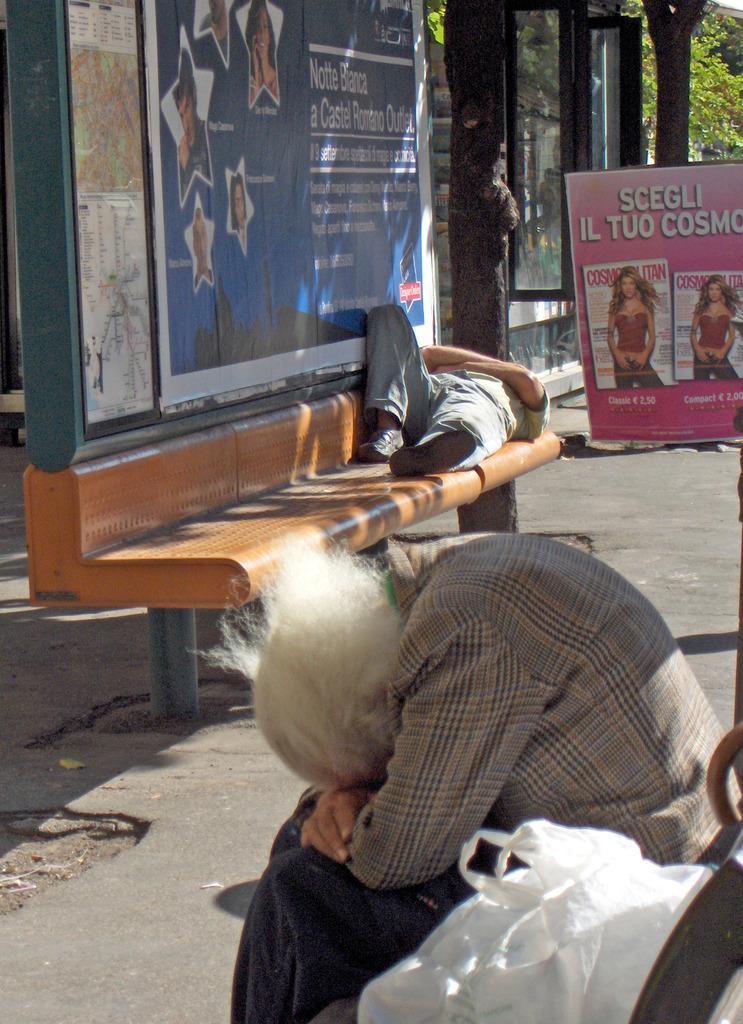Could you give a brief overview of what you see in this image? In the center of the image we can see a man is lying on a bench. At the bottom of the image we can see a person is sitting on a bench and also we can see plastic cover. In the background of the image we can see the boards, trees. In the middle of the image we can see the road. 